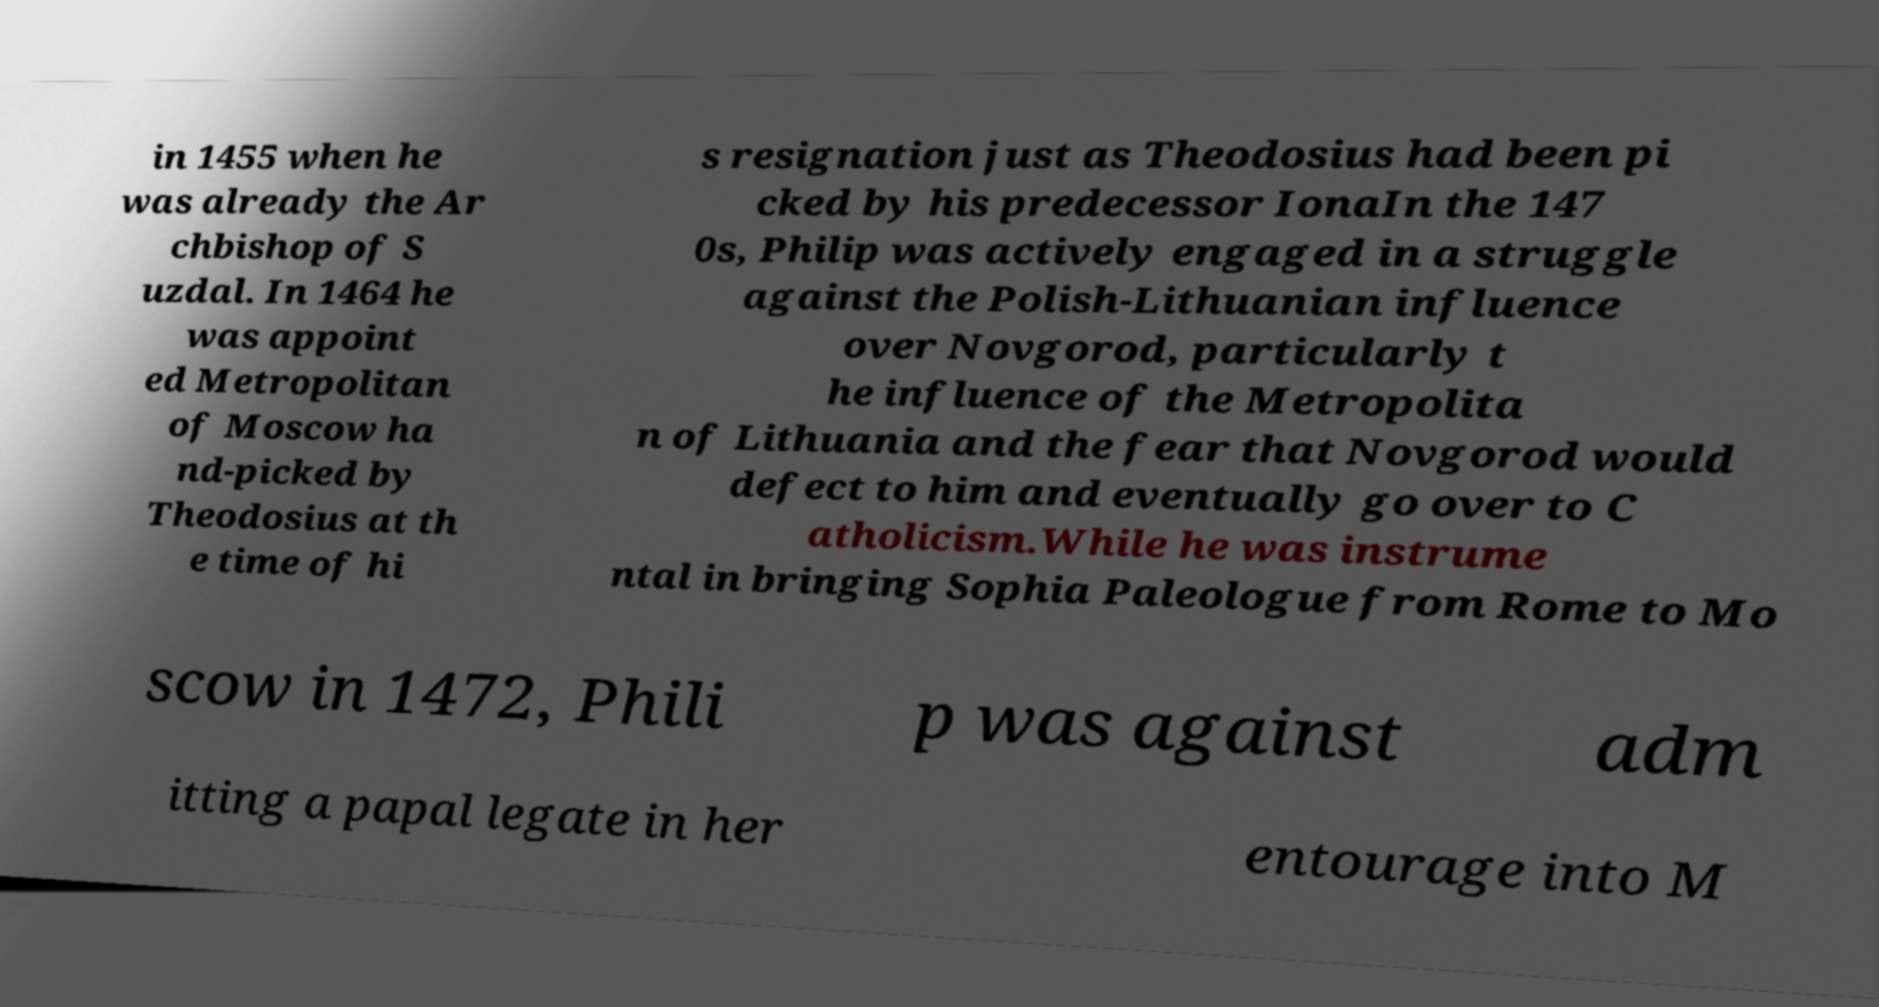I need the written content from this picture converted into text. Can you do that? in 1455 when he was already the Ar chbishop of S uzdal. In 1464 he was appoint ed Metropolitan of Moscow ha nd-picked by Theodosius at th e time of hi s resignation just as Theodosius had been pi cked by his predecessor IonaIn the 147 0s, Philip was actively engaged in a struggle against the Polish-Lithuanian influence over Novgorod, particularly t he influence of the Metropolita n of Lithuania and the fear that Novgorod would defect to him and eventually go over to C atholicism.While he was instrume ntal in bringing Sophia Paleologue from Rome to Mo scow in 1472, Phili p was against adm itting a papal legate in her entourage into M 